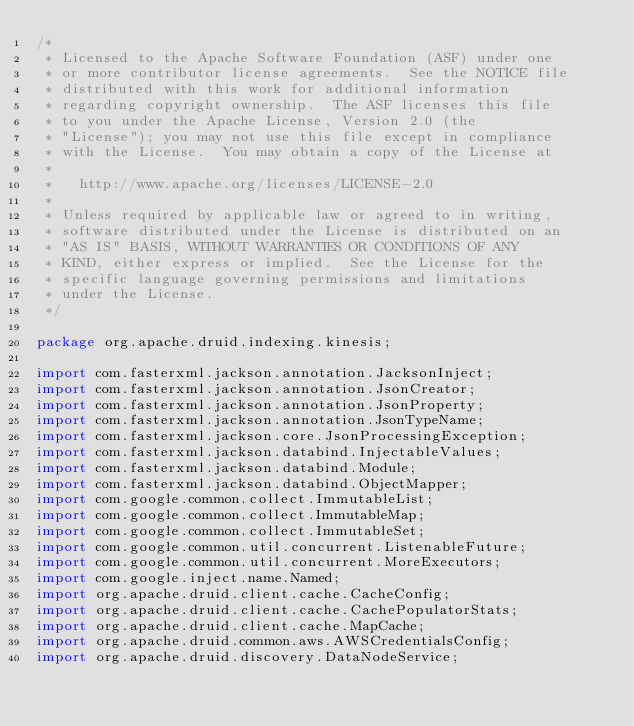<code> <loc_0><loc_0><loc_500><loc_500><_Java_>/*
 * Licensed to the Apache Software Foundation (ASF) under one
 * or more contributor license agreements.  See the NOTICE file
 * distributed with this work for additional information
 * regarding copyright ownership.  The ASF licenses this file
 * to you under the Apache License, Version 2.0 (the
 * "License"); you may not use this file except in compliance
 * with the License.  You may obtain a copy of the License at
 *
 *   http://www.apache.org/licenses/LICENSE-2.0
 *
 * Unless required by applicable law or agreed to in writing,
 * software distributed under the License is distributed on an
 * "AS IS" BASIS, WITHOUT WARRANTIES OR CONDITIONS OF ANY
 * KIND, either express or implied.  See the License for the
 * specific language governing permissions and limitations
 * under the License.
 */

package org.apache.druid.indexing.kinesis;

import com.fasterxml.jackson.annotation.JacksonInject;
import com.fasterxml.jackson.annotation.JsonCreator;
import com.fasterxml.jackson.annotation.JsonProperty;
import com.fasterxml.jackson.annotation.JsonTypeName;
import com.fasterxml.jackson.core.JsonProcessingException;
import com.fasterxml.jackson.databind.InjectableValues;
import com.fasterxml.jackson.databind.Module;
import com.fasterxml.jackson.databind.ObjectMapper;
import com.google.common.collect.ImmutableList;
import com.google.common.collect.ImmutableMap;
import com.google.common.collect.ImmutableSet;
import com.google.common.util.concurrent.ListenableFuture;
import com.google.common.util.concurrent.MoreExecutors;
import com.google.inject.name.Named;
import org.apache.druid.client.cache.CacheConfig;
import org.apache.druid.client.cache.CachePopulatorStats;
import org.apache.druid.client.cache.MapCache;
import org.apache.druid.common.aws.AWSCredentialsConfig;
import org.apache.druid.discovery.DataNodeService;</code> 